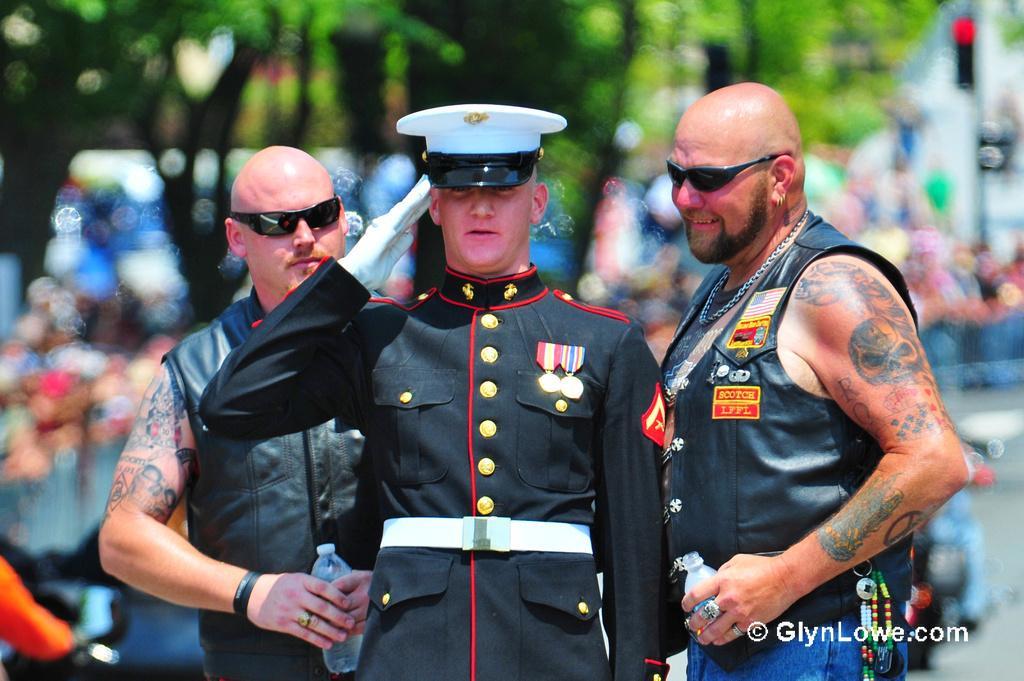How would you summarize this image in a sentence or two? In this picture there is a police officer, beside him there are two bald man who is wearing a goggles, jacket, trouser and holding the water bottle. In the back I can see the blur image. In the background I can see the trees, plants, papers and traffic signal. In the bottom right corner there is a watermark. 